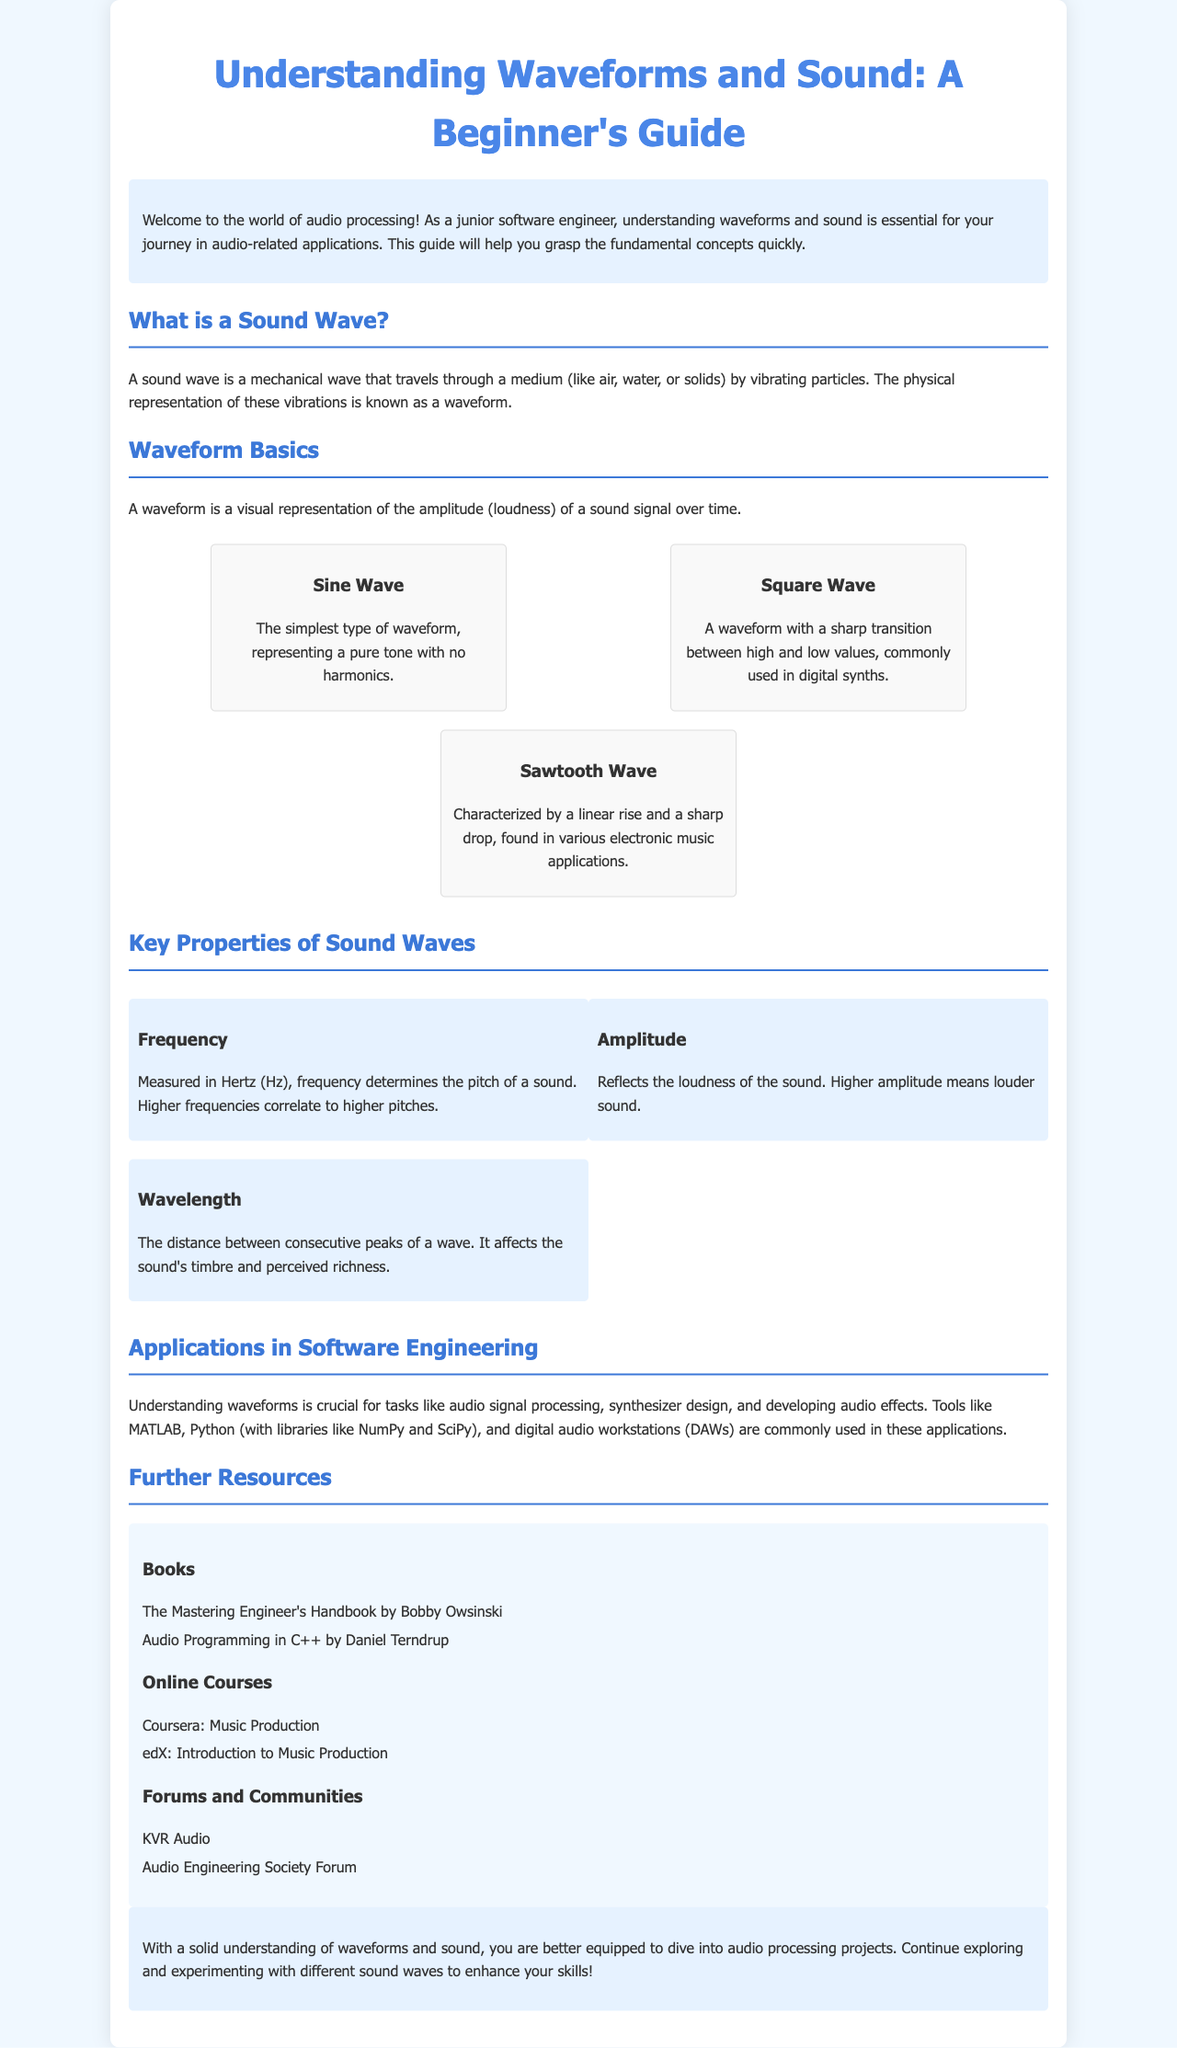What is the title of the guide? The title of the guide is prominently displayed at the beginning of the document.
Answer: Understanding Waveforms and Sound: A Beginner's Guide What type of wave is the simplest? The document mentions several types of waves, specifying one as the simplest type.
Answer: Sine Wave What is frequency measured in? The key properties section states the unit for measuring frequency explicitly.
Answer: Hertz What effect does higher amplitude have on sound? The document describes the impact of amplitude on sound loudness directly.
Answer: Louder sound Which two libraries are mentioned for Python? The applications section lists specific libraries used for audio processing tasks in Python.
Answer: NumPy and SciPy What type of wave is characterized by a linear rise and a sharp drop? The guide describes various wave types with specific characteristics.
Answer: Sawtooth Wave Which book is written by Bobby Owsinski? The resources section lists books related to audio processing, naming the author alongside the book title.
Answer: The Mastering Engineer's Handbook What is the distance between consecutive peaks called? The document explains a fundamental term relating to wave properties in the key properties section.
Answer: Wavelength Name one online course mentioned in the brochure. The resources section lists educational courses related to music production.
Answer: Music Production 